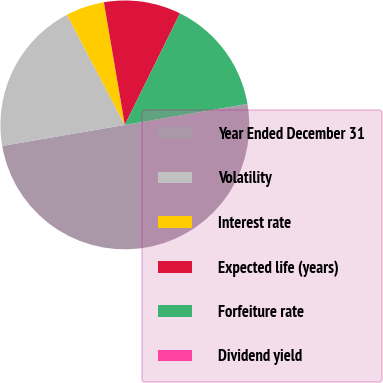Convert chart to OTSL. <chart><loc_0><loc_0><loc_500><loc_500><pie_chart><fcel>Year Ended December 31<fcel>Volatility<fcel>Interest rate<fcel>Expected life (years)<fcel>Forfeiture rate<fcel>Dividend yield<nl><fcel>49.98%<fcel>20.0%<fcel>5.01%<fcel>10.0%<fcel>15.0%<fcel>0.01%<nl></chart> 